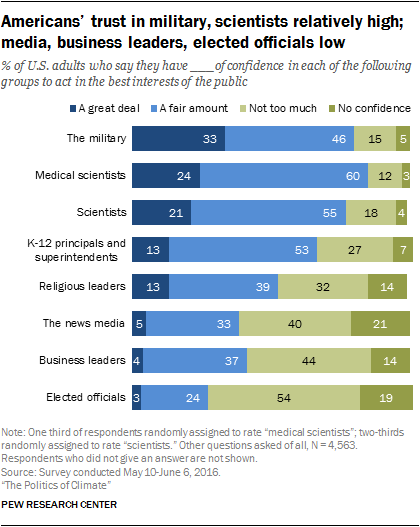Highlight a few significant elements in this photo. According to the data, Americans trust scientists more than the news media by a small but significant margin of 0.16. What do Americans trust the most? The military. 